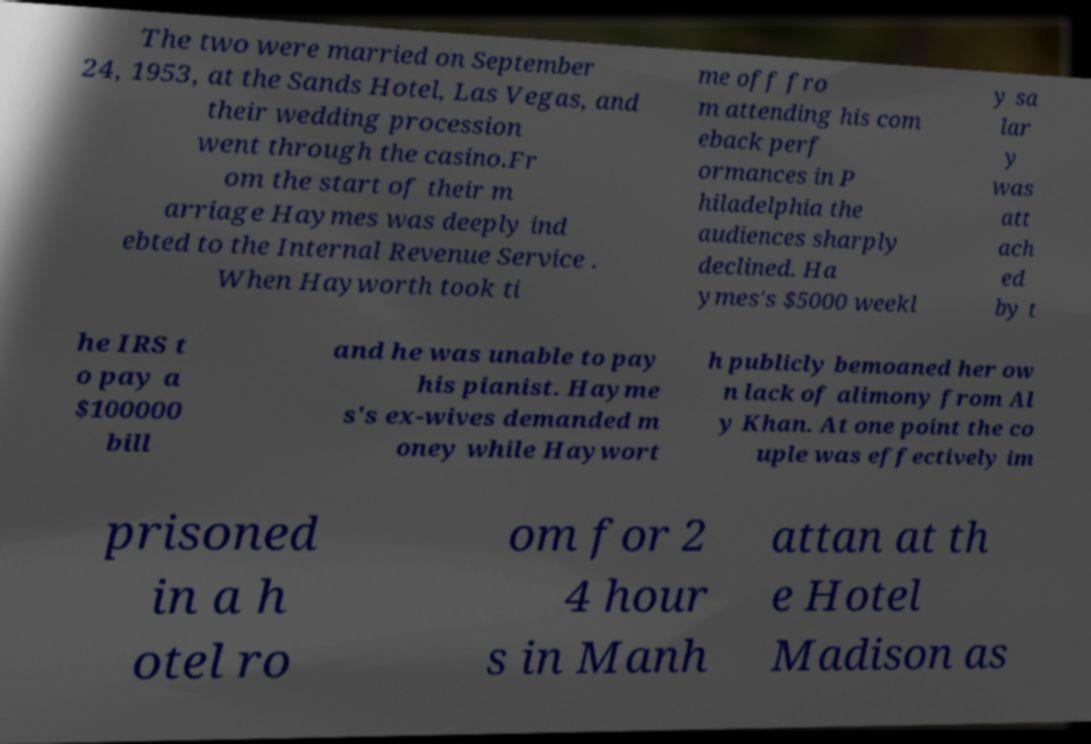Please read and relay the text visible in this image. What does it say? The two were married on September 24, 1953, at the Sands Hotel, Las Vegas, and their wedding procession went through the casino.Fr om the start of their m arriage Haymes was deeply ind ebted to the Internal Revenue Service . When Hayworth took ti me off fro m attending his com eback perf ormances in P hiladelphia the audiences sharply declined. Ha ymes's $5000 weekl y sa lar y was att ach ed by t he IRS t o pay a $100000 bill and he was unable to pay his pianist. Hayme s's ex-wives demanded m oney while Haywort h publicly bemoaned her ow n lack of alimony from Al y Khan. At one point the co uple was effectively im prisoned in a h otel ro om for 2 4 hour s in Manh attan at th e Hotel Madison as 